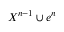Convert formula to latex. <formula><loc_0><loc_0><loc_500><loc_500>X ^ { n - 1 } \cup e ^ { n }</formula> 